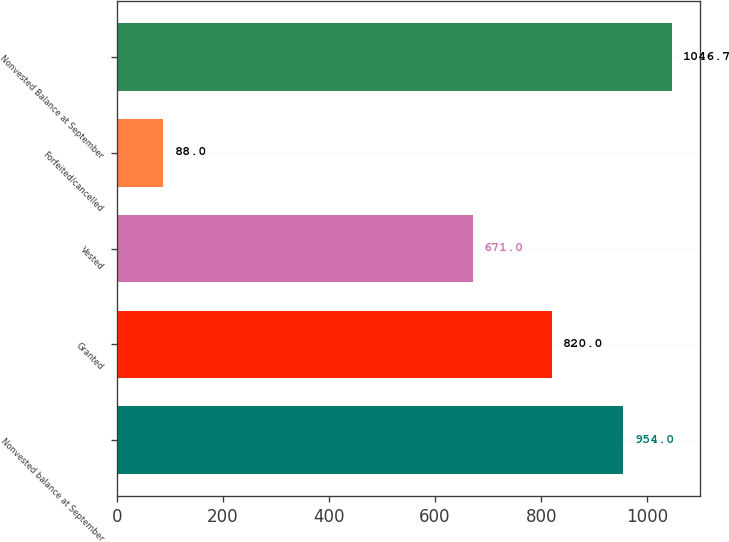<chart> <loc_0><loc_0><loc_500><loc_500><bar_chart><fcel>Nonvested balance at September<fcel>Granted<fcel>Vested<fcel>Forfeited/cancelled<fcel>Nonvested Balance at September<nl><fcel>954<fcel>820<fcel>671<fcel>88<fcel>1046.7<nl></chart> 